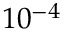Convert formula to latex. <formula><loc_0><loc_0><loc_500><loc_500>1 0 ^ { - 4 }</formula> 